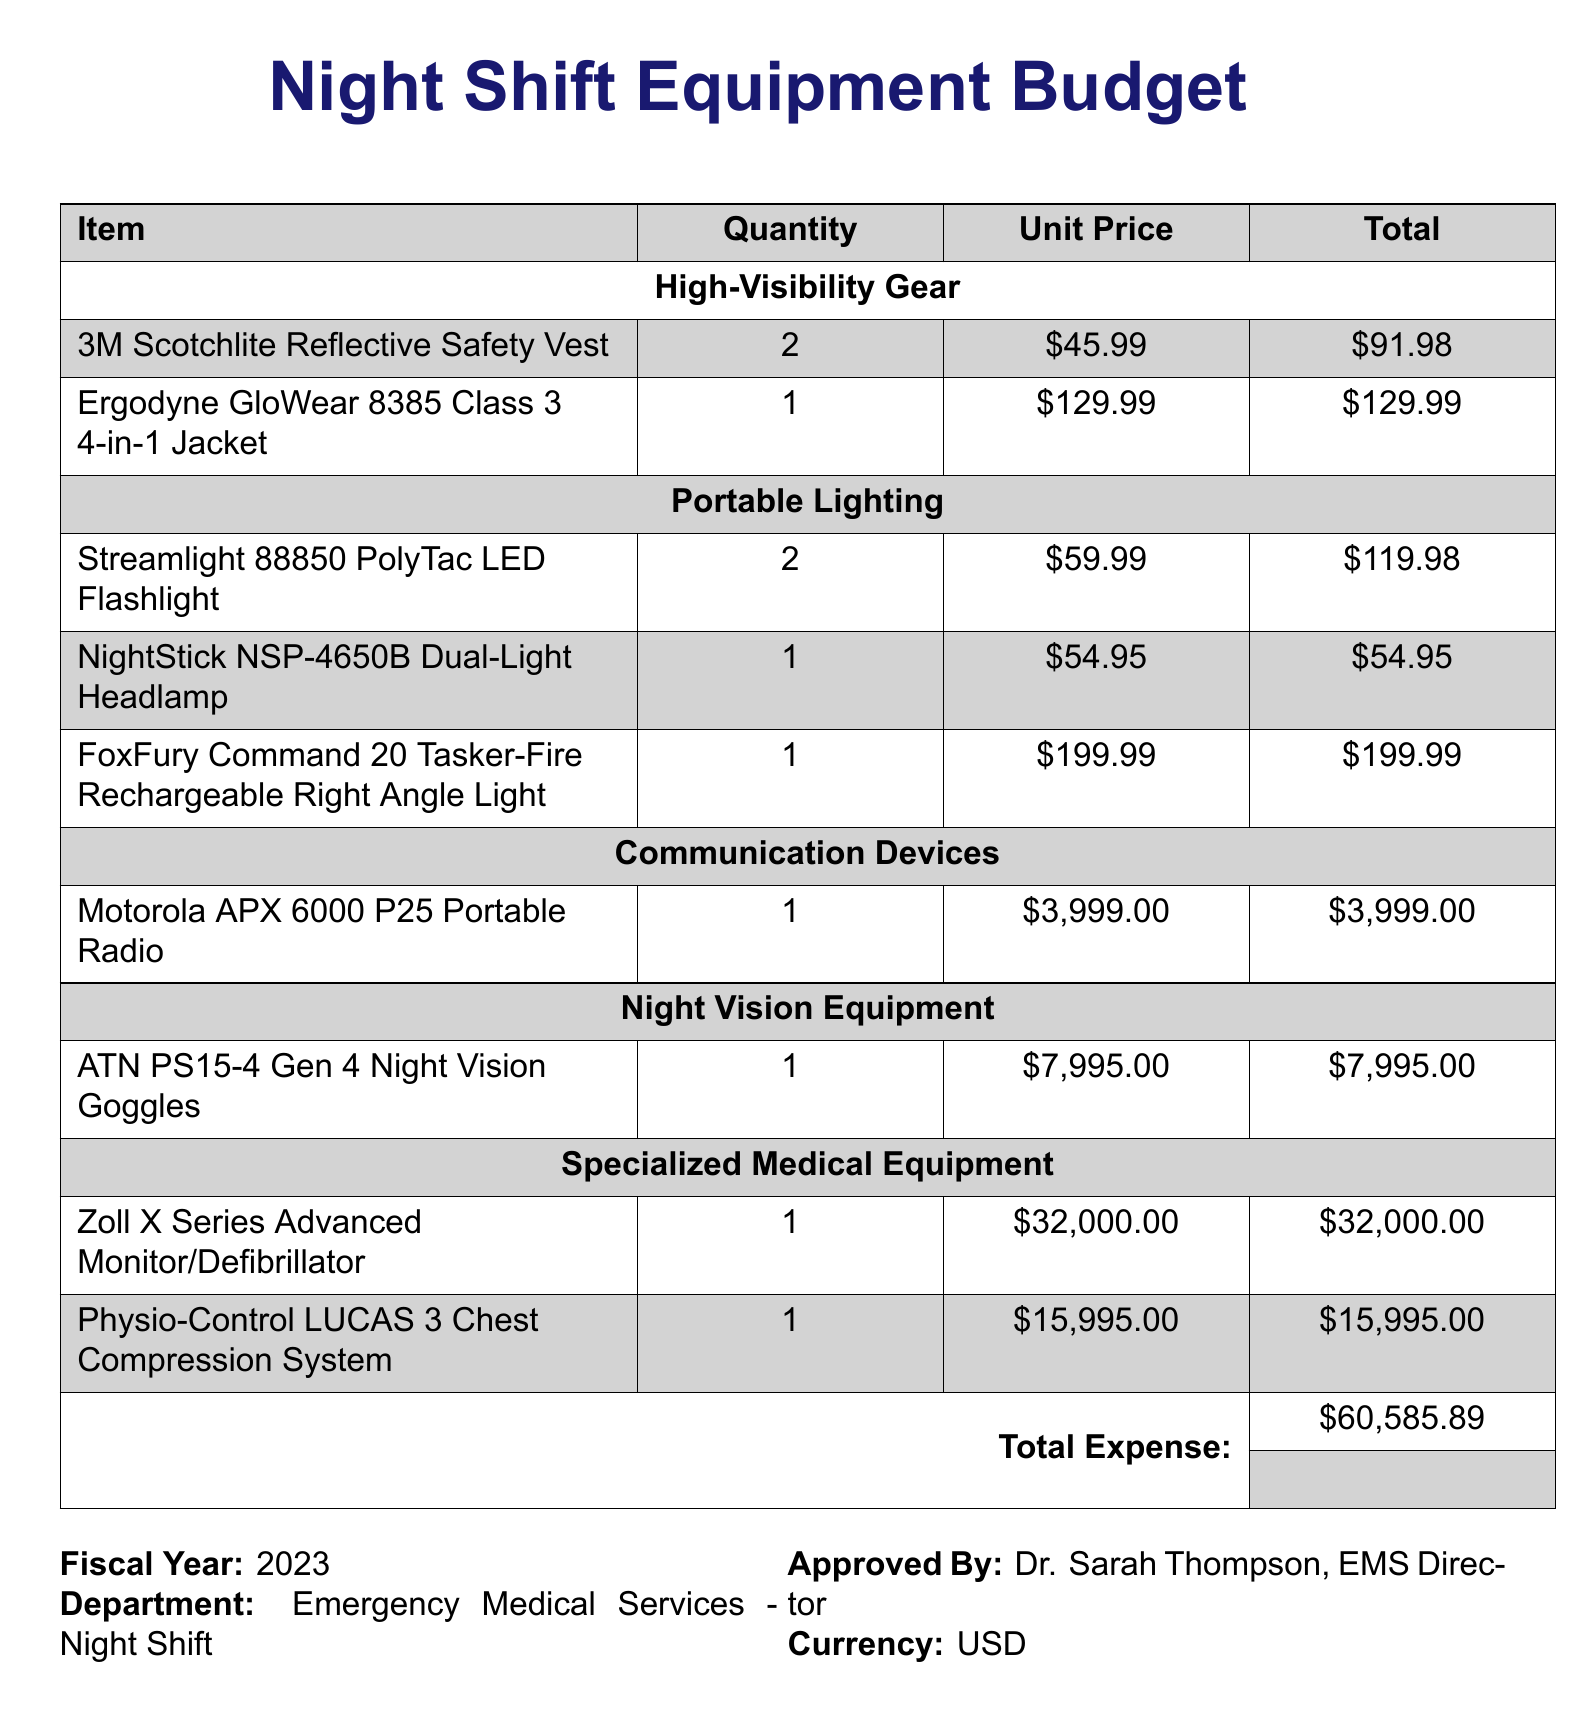What is the total expense? The total expense is the sum of all items listed in the budget, resulting in a total of $60,585.89.
Answer: $60,585.89 What is the quantity of 3M Scotchlite Reflective Safety Vests? The quantity of 3M Scotchlite Reflective Safety Vests listed in the document is 2.
Answer: 2 Who approved the budget? The approval is indicated in the document as Dr. Sarah Thompson, the EMS Director.
Answer: Dr. Sarah Thompson How many Portable Lighting items are listed? The document lists three items under Portable Lighting.
Answer: 3 What is the unit price of the Motorola APX 6000 P25 Portable Radio? The unit price specified in the document for the Motorola APX 6000 P25 Portable Radio is $3,999.00.
Answer: $3,999.00 What specialized medical equipment has the highest cost? The highest cost specialized medical equipment mentioned in the document is the Zoll X Series Advanced Monitor/Defibrillator.
Answer: Zoll X Series Advanced Monitor/Defibrillator Which department is this budget for? The budget is specifically for the Emergency Medical Services - Night Shift department.
Answer: Emergency Medical Services - Night Shift What is the unit price of the NightStick NSP-4650B Dual-Light Headlamp? The unit price of the NightStick NSP-4650B Dual-Light Headlamp listed in the document is $54.95.
Answer: $54.95 